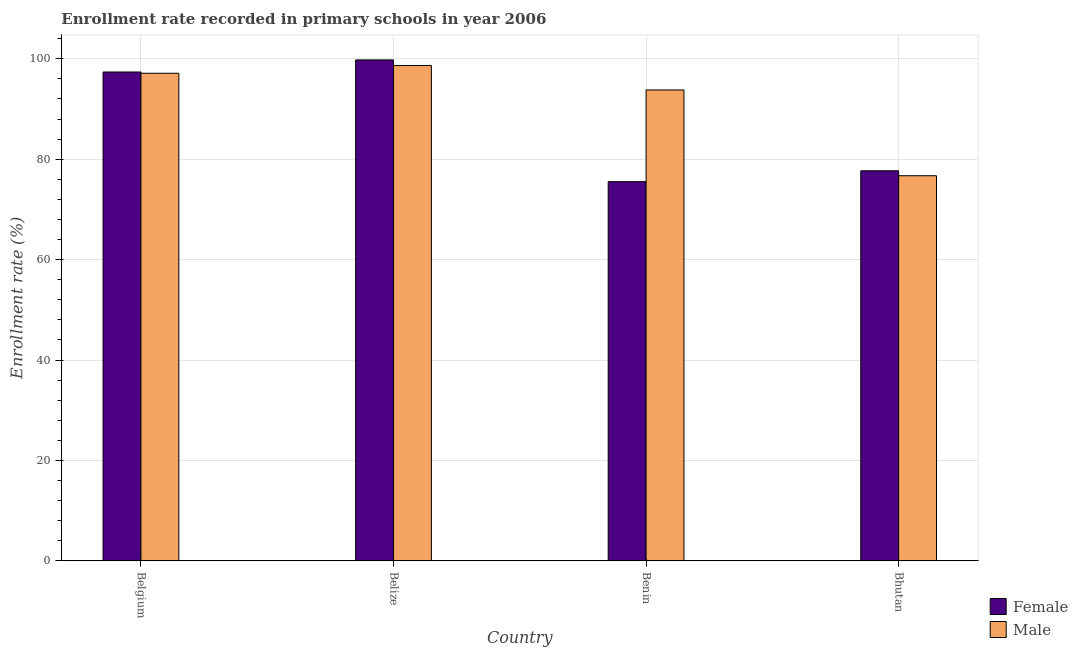How many different coloured bars are there?
Your answer should be compact. 2. Are the number of bars on each tick of the X-axis equal?
Your response must be concise. Yes. How many bars are there on the 1st tick from the left?
Offer a very short reply. 2. In how many cases, is the number of bars for a given country not equal to the number of legend labels?
Provide a short and direct response. 0. What is the enrollment rate of female students in Bhutan?
Provide a succinct answer. 77.7. Across all countries, what is the maximum enrollment rate of female students?
Your answer should be compact. 99.78. Across all countries, what is the minimum enrollment rate of female students?
Your answer should be compact. 75.54. In which country was the enrollment rate of male students maximum?
Give a very brief answer. Belize. In which country was the enrollment rate of male students minimum?
Your response must be concise. Bhutan. What is the total enrollment rate of female students in the graph?
Ensure brevity in your answer.  350.4. What is the difference between the enrollment rate of male students in Belize and that in Benin?
Offer a very short reply. 4.87. What is the difference between the enrollment rate of female students in Benin and the enrollment rate of male students in Belize?
Make the answer very short. -23.13. What is the average enrollment rate of male students per country?
Provide a succinct answer. 91.58. What is the difference between the enrollment rate of female students and enrollment rate of male students in Bhutan?
Offer a very short reply. 0.98. In how many countries, is the enrollment rate of male students greater than 48 %?
Keep it short and to the point. 4. What is the ratio of the enrollment rate of female students in Benin to that in Bhutan?
Provide a short and direct response. 0.97. Is the enrollment rate of male students in Belgium less than that in Benin?
Offer a very short reply. No. What is the difference between the highest and the second highest enrollment rate of male students?
Offer a very short reply. 1.54. What is the difference between the highest and the lowest enrollment rate of male students?
Your answer should be very brief. 21.95. In how many countries, is the enrollment rate of female students greater than the average enrollment rate of female students taken over all countries?
Keep it short and to the point. 2. Is the sum of the enrollment rate of male students in Belgium and Belize greater than the maximum enrollment rate of female students across all countries?
Your answer should be compact. Yes. What does the 2nd bar from the right in Belize represents?
Give a very brief answer. Female. How many bars are there?
Provide a short and direct response. 8. Are all the bars in the graph horizontal?
Offer a terse response. No. Where does the legend appear in the graph?
Provide a succinct answer. Bottom right. How are the legend labels stacked?
Offer a terse response. Vertical. What is the title of the graph?
Offer a terse response. Enrollment rate recorded in primary schools in year 2006. What is the label or title of the X-axis?
Provide a succinct answer. Country. What is the label or title of the Y-axis?
Your response must be concise. Enrollment rate (%). What is the Enrollment rate (%) in Female in Belgium?
Provide a succinct answer. 97.38. What is the Enrollment rate (%) of Male in Belgium?
Your response must be concise. 97.12. What is the Enrollment rate (%) in Female in Belize?
Your answer should be compact. 99.78. What is the Enrollment rate (%) of Male in Belize?
Your answer should be compact. 98.67. What is the Enrollment rate (%) of Female in Benin?
Give a very brief answer. 75.54. What is the Enrollment rate (%) in Male in Benin?
Ensure brevity in your answer.  93.8. What is the Enrollment rate (%) in Female in Bhutan?
Your response must be concise. 77.7. What is the Enrollment rate (%) of Male in Bhutan?
Keep it short and to the point. 76.72. Across all countries, what is the maximum Enrollment rate (%) in Female?
Your answer should be compact. 99.78. Across all countries, what is the maximum Enrollment rate (%) in Male?
Provide a succinct answer. 98.67. Across all countries, what is the minimum Enrollment rate (%) of Female?
Keep it short and to the point. 75.54. Across all countries, what is the minimum Enrollment rate (%) of Male?
Offer a terse response. 76.72. What is the total Enrollment rate (%) of Female in the graph?
Your answer should be very brief. 350.4. What is the total Enrollment rate (%) in Male in the graph?
Ensure brevity in your answer.  366.31. What is the difference between the Enrollment rate (%) in Female in Belgium and that in Belize?
Your response must be concise. -2.4. What is the difference between the Enrollment rate (%) in Male in Belgium and that in Belize?
Offer a very short reply. -1.54. What is the difference between the Enrollment rate (%) in Female in Belgium and that in Benin?
Your response must be concise. 21.84. What is the difference between the Enrollment rate (%) in Male in Belgium and that in Benin?
Offer a very short reply. 3.32. What is the difference between the Enrollment rate (%) of Female in Belgium and that in Bhutan?
Provide a succinct answer. 19.68. What is the difference between the Enrollment rate (%) of Male in Belgium and that in Bhutan?
Your answer should be very brief. 20.4. What is the difference between the Enrollment rate (%) of Female in Belize and that in Benin?
Your response must be concise. 24.24. What is the difference between the Enrollment rate (%) in Male in Belize and that in Benin?
Offer a very short reply. 4.87. What is the difference between the Enrollment rate (%) in Female in Belize and that in Bhutan?
Your answer should be compact. 22.08. What is the difference between the Enrollment rate (%) in Male in Belize and that in Bhutan?
Provide a short and direct response. 21.95. What is the difference between the Enrollment rate (%) in Female in Benin and that in Bhutan?
Your response must be concise. -2.16. What is the difference between the Enrollment rate (%) of Male in Benin and that in Bhutan?
Your answer should be very brief. 17.08. What is the difference between the Enrollment rate (%) in Female in Belgium and the Enrollment rate (%) in Male in Belize?
Keep it short and to the point. -1.29. What is the difference between the Enrollment rate (%) in Female in Belgium and the Enrollment rate (%) in Male in Benin?
Ensure brevity in your answer.  3.58. What is the difference between the Enrollment rate (%) of Female in Belgium and the Enrollment rate (%) of Male in Bhutan?
Provide a short and direct response. 20.66. What is the difference between the Enrollment rate (%) in Female in Belize and the Enrollment rate (%) in Male in Benin?
Offer a very short reply. 5.98. What is the difference between the Enrollment rate (%) in Female in Belize and the Enrollment rate (%) in Male in Bhutan?
Your answer should be very brief. 23.06. What is the difference between the Enrollment rate (%) in Female in Benin and the Enrollment rate (%) in Male in Bhutan?
Give a very brief answer. -1.18. What is the average Enrollment rate (%) in Female per country?
Offer a very short reply. 87.6. What is the average Enrollment rate (%) of Male per country?
Make the answer very short. 91.58. What is the difference between the Enrollment rate (%) in Female and Enrollment rate (%) in Male in Belgium?
Make the answer very short. 0.26. What is the difference between the Enrollment rate (%) of Female and Enrollment rate (%) of Male in Belize?
Make the answer very short. 1.12. What is the difference between the Enrollment rate (%) in Female and Enrollment rate (%) in Male in Benin?
Provide a short and direct response. -18.26. What is the difference between the Enrollment rate (%) of Female and Enrollment rate (%) of Male in Bhutan?
Your response must be concise. 0.98. What is the ratio of the Enrollment rate (%) of Female in Belgium to that in Belize?
Ensure brevity in your answer.  0.98. What is the ratio of the Enrollment rate (%) in Male in Belgium to that in Belize?
Your response must be concise. 0.98. What is the ratio of the Enrollment rate (%) of Female in Belgium to that in Benin?
Make the answer very short. 1.29. What is the ratio of the Enrollment rate (%) of Male in Belgium to that in Benin?
Give a very brief answer. 1.04. What is the ratio of the Enrollment rate (%) in Female in Belgium to that in Bhutan?
Your response must be concise. 1.25. What is the ratio of the Enrollment rate (%) in Male in Belgium to that in Bhutan?
Ensure brevity in your answer.  1.27. What is the ratio of the Enrollment rate (%) of Female in Belize to that in Benin?
Offer a terse response. 1.32. What is the ratio of the Enrollment rate (%) in Male in Belize to that in Benin?
Provide a short and direct response. 1.05. What is the ratio of the Enrollment rate (%) of Female in Belize to that in Bhutan?
Your answer should be compact. 1.28. What is the ratio of the Enrollment rate (%) of Male in Belize to that in Bhutan?
Offer a very short reply. 1.29. What is the ratio of the Enrollment rate (%) of Female in Benin to that in Bhutan?
Offer a very short reply. 0.97. What is the ratio of the Enrollment rate (%) in Male in Benin to that in Bhutan?
Your response must be concise. 1.22. What is the difference between the highest and the second highest Enrollment rate (%) in Female?
Ensure brevity in your answer.  2.4. What is the difference between the highest and the second highest Enrollment rate (%) in Male?
Your answer should be very brief. 1.54. What is the difference between the highest and the lowest Enrollment rate (%) in Female?
Your answer should be very brief. 24.24. What is the difference between the highest and the lowest Enrollment rate (%) of Male?
Provide a short and direct response. 21.95. 